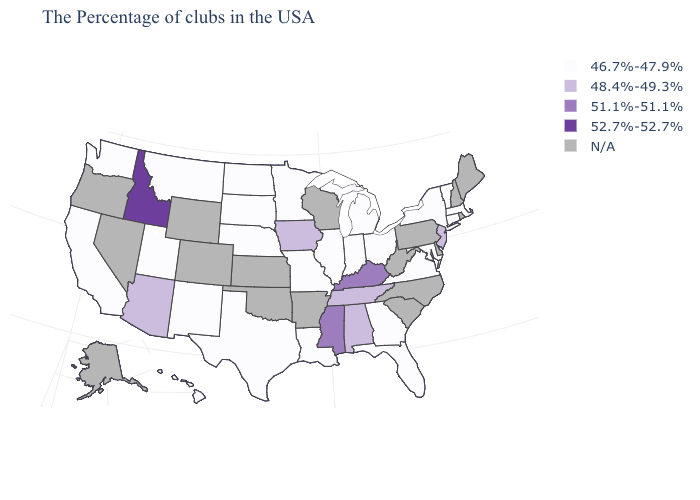What is the highest value in the USA?
Quick response, please. 52.7%-52.7%. What is the value of Alabama?
Give a very brief answer. 48.4%-49.3%. Name the states that have a value in the range 48.4%-49.3%?
Answer briefly. New Jersey, Alabama, Tennessee, Iowa, Arizona. Name the states that have a value in the range 52.7%-52.7%?
Write a very short answer. Idaho. Name the states that have a value in the range 52.7%-52.7%?
Quick response, please. Idaho. What is the value of New York?
Quick response, please. 46.7%-47.9%. What is the value of Oregon?
Short answer required. N/A. What is the value of Indiana?
Answer briefly. 46.7%-47.9%. What is the value of Alabama?
Write a very short answer. 48.4%-49.3%. Among the states that border Oregon , which have the lowest value?
Short answer required. California, Washington. What is the lowest value in the South?
Answer briefly. 46.7%-47.9%. Does New Jersey have the lowest value in the Northeast?
Be succinct. No. 